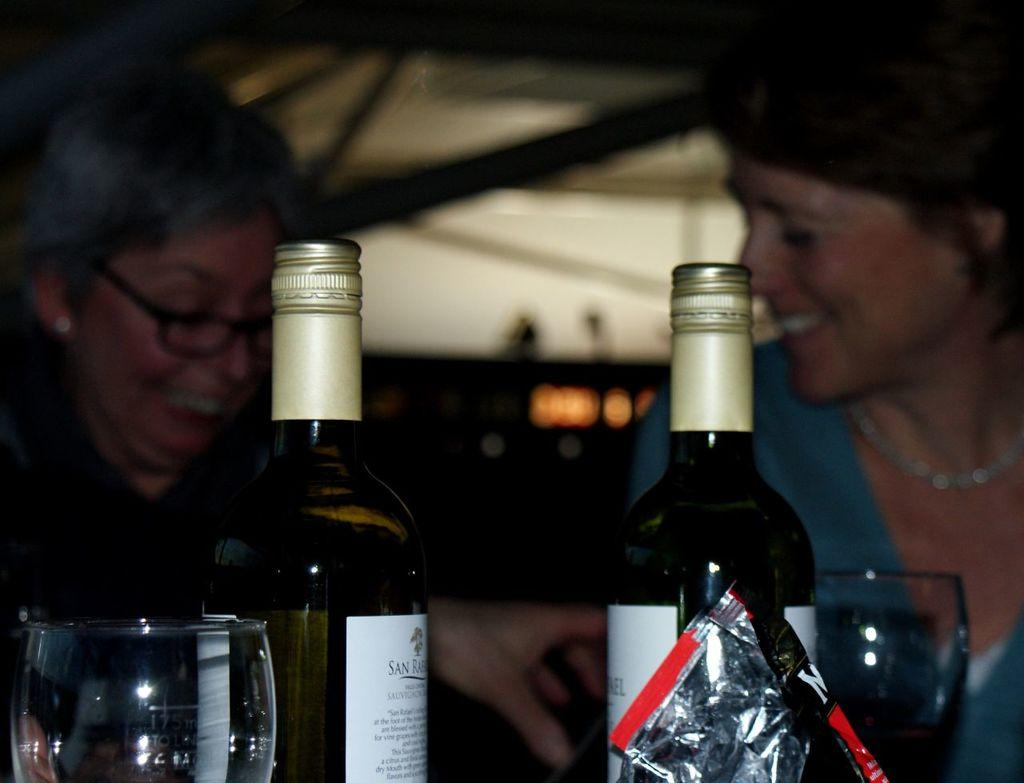How many women are in the image? There are two women in the image. What expression do the women have? The women are smiling. What objects can be seen in the image besides the women? There are bottles, glasses, a packet, and lights in the image. What is the condition of the background in the image? The background of the image is blurry. What type of pain is the woman on the left experiencing in the image? There is no indication of pain in the image; both women are smiling. What line can be seen in the image? There is no line present in the image. 